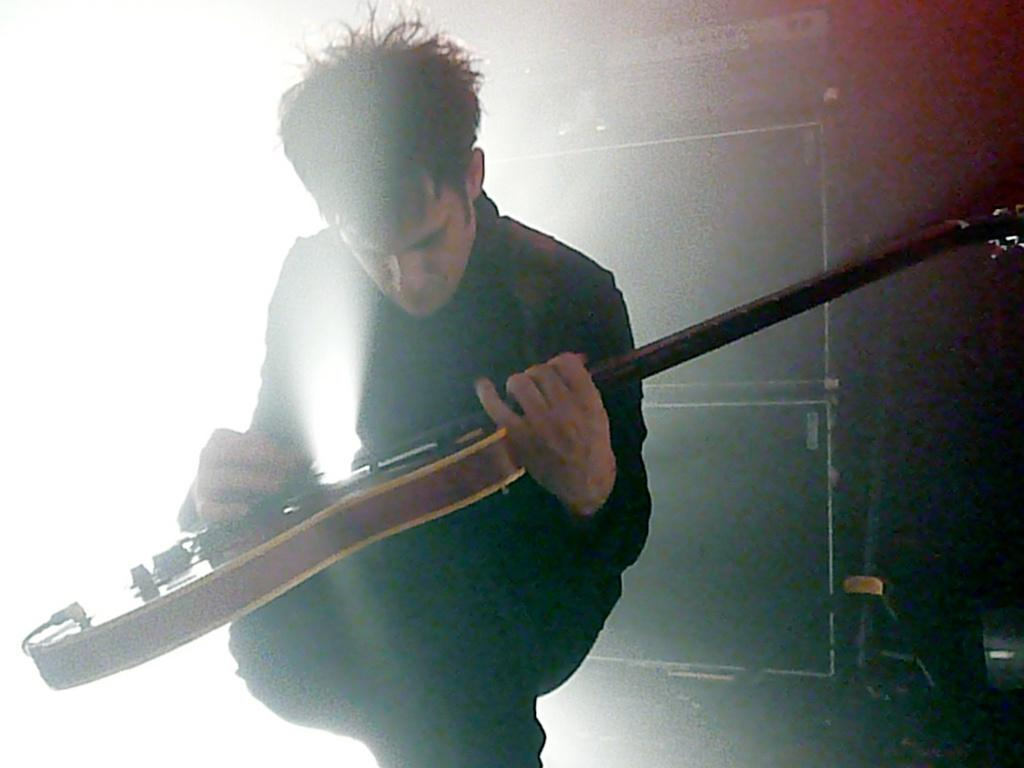What is present in the image? There is a man in the image. What is the man holding in the image? The man is holding a musical instrument. What type of quiver is the man using to hold his musical instrument in the image? There is no quiver present in the image; the man is simply holding the musical instrument. What type of seed can be seen growing near the man in the image? There are no seeds present in the image. 